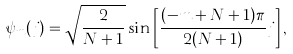<formula> <loc_0><loc_0><loc_500><loc_500>\psi _ { m } ( j ) = \sqrt { \frac { 2 } { N + 1 } } \sin \left [ \frac { ( - m + N + 1 ) \pi } { 2 ( N + 1 ) } j \right ] ,</formula> 